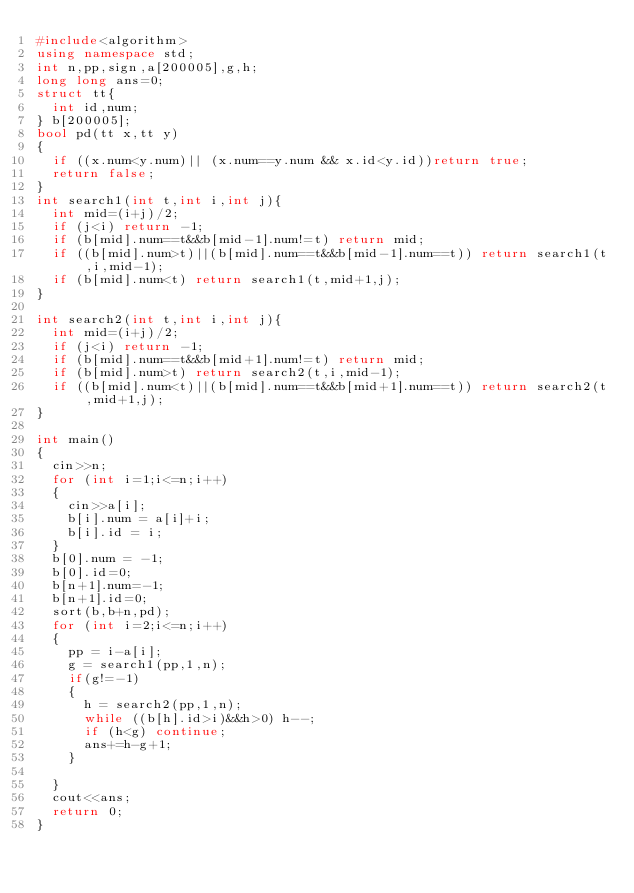<code> <loc_0><loc_0><loc_500><loc_500><_C++_>#include<algorithm>
using namespace std;
int n,pp,sign,a[200005],g,h;
long long ans=0;
struct tt{
	int id,num;
} b[200005];
bool pd(tt x,tt y)
{
	if ((x.num<y.num)|| (x.num==y.num && x.id<y.id))return true;
	return false;
}
int search1(int t,int i,int j){
	int mid=(i+j)/2;
	if (j<i) return -1;
	if (b[mid].num==t&&b[mid-1].num!=t) return mid;
	if ((b[mid].num>t)||(b[mid].num==t&&b[mid-1].num==t)) return search1(t,i,mid-1);
	if (b[mid].num<t) return search1(t,mid+1,j);
}

int search2(int t,int i,int j){
	int mid=(i+j)/2;
	if (j<i) return -1;
	if (b[mid].num==t&&b[mid+1].num!=t) return mid;
	if (b[mid].num>t) return search2(t,i,mid-1);
	if ((b[mid].num<t)||(b[mid].num==t&&b[mid+1].num==t)) return search2(t,mid+1,j);
}

int main()
{
	cin>>n;
	for (int i=1;i<=n;i++)
	{
		cin>>a[i];
		b[i].num = a[i]+i;
		b[i].id = i;
	}
	b[0].num = -1;
	b[0].id=0;
	b[n+1].num=-1;
	b[n+1].id=0;
	sort(b,b+n,pd);
	for (int i=2;i<=n;i++)
	{
		pp = i-a[i];
		g = search1(pp,1,n);
		if(g!=-1)
		{
			h = search2(pp,1,n);
			while ((b[h].id>i)&&h>0) h--;
			if (h<g) continue;
			ans+=h-g+1;
		}
		
	}
	cout<<ans;
	return 0;
}
	</code> 